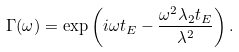<formula> <loc_0><loc_0><loc_500><loc_500>\Gamma ( \omega ) = \exp \left ( i \omega t _ { E } - \frac { \omega ^ { 2 } \lambda _ { 2 } t _ { E } } { \lambda ^ { 2 } } \right ) .</formula> 